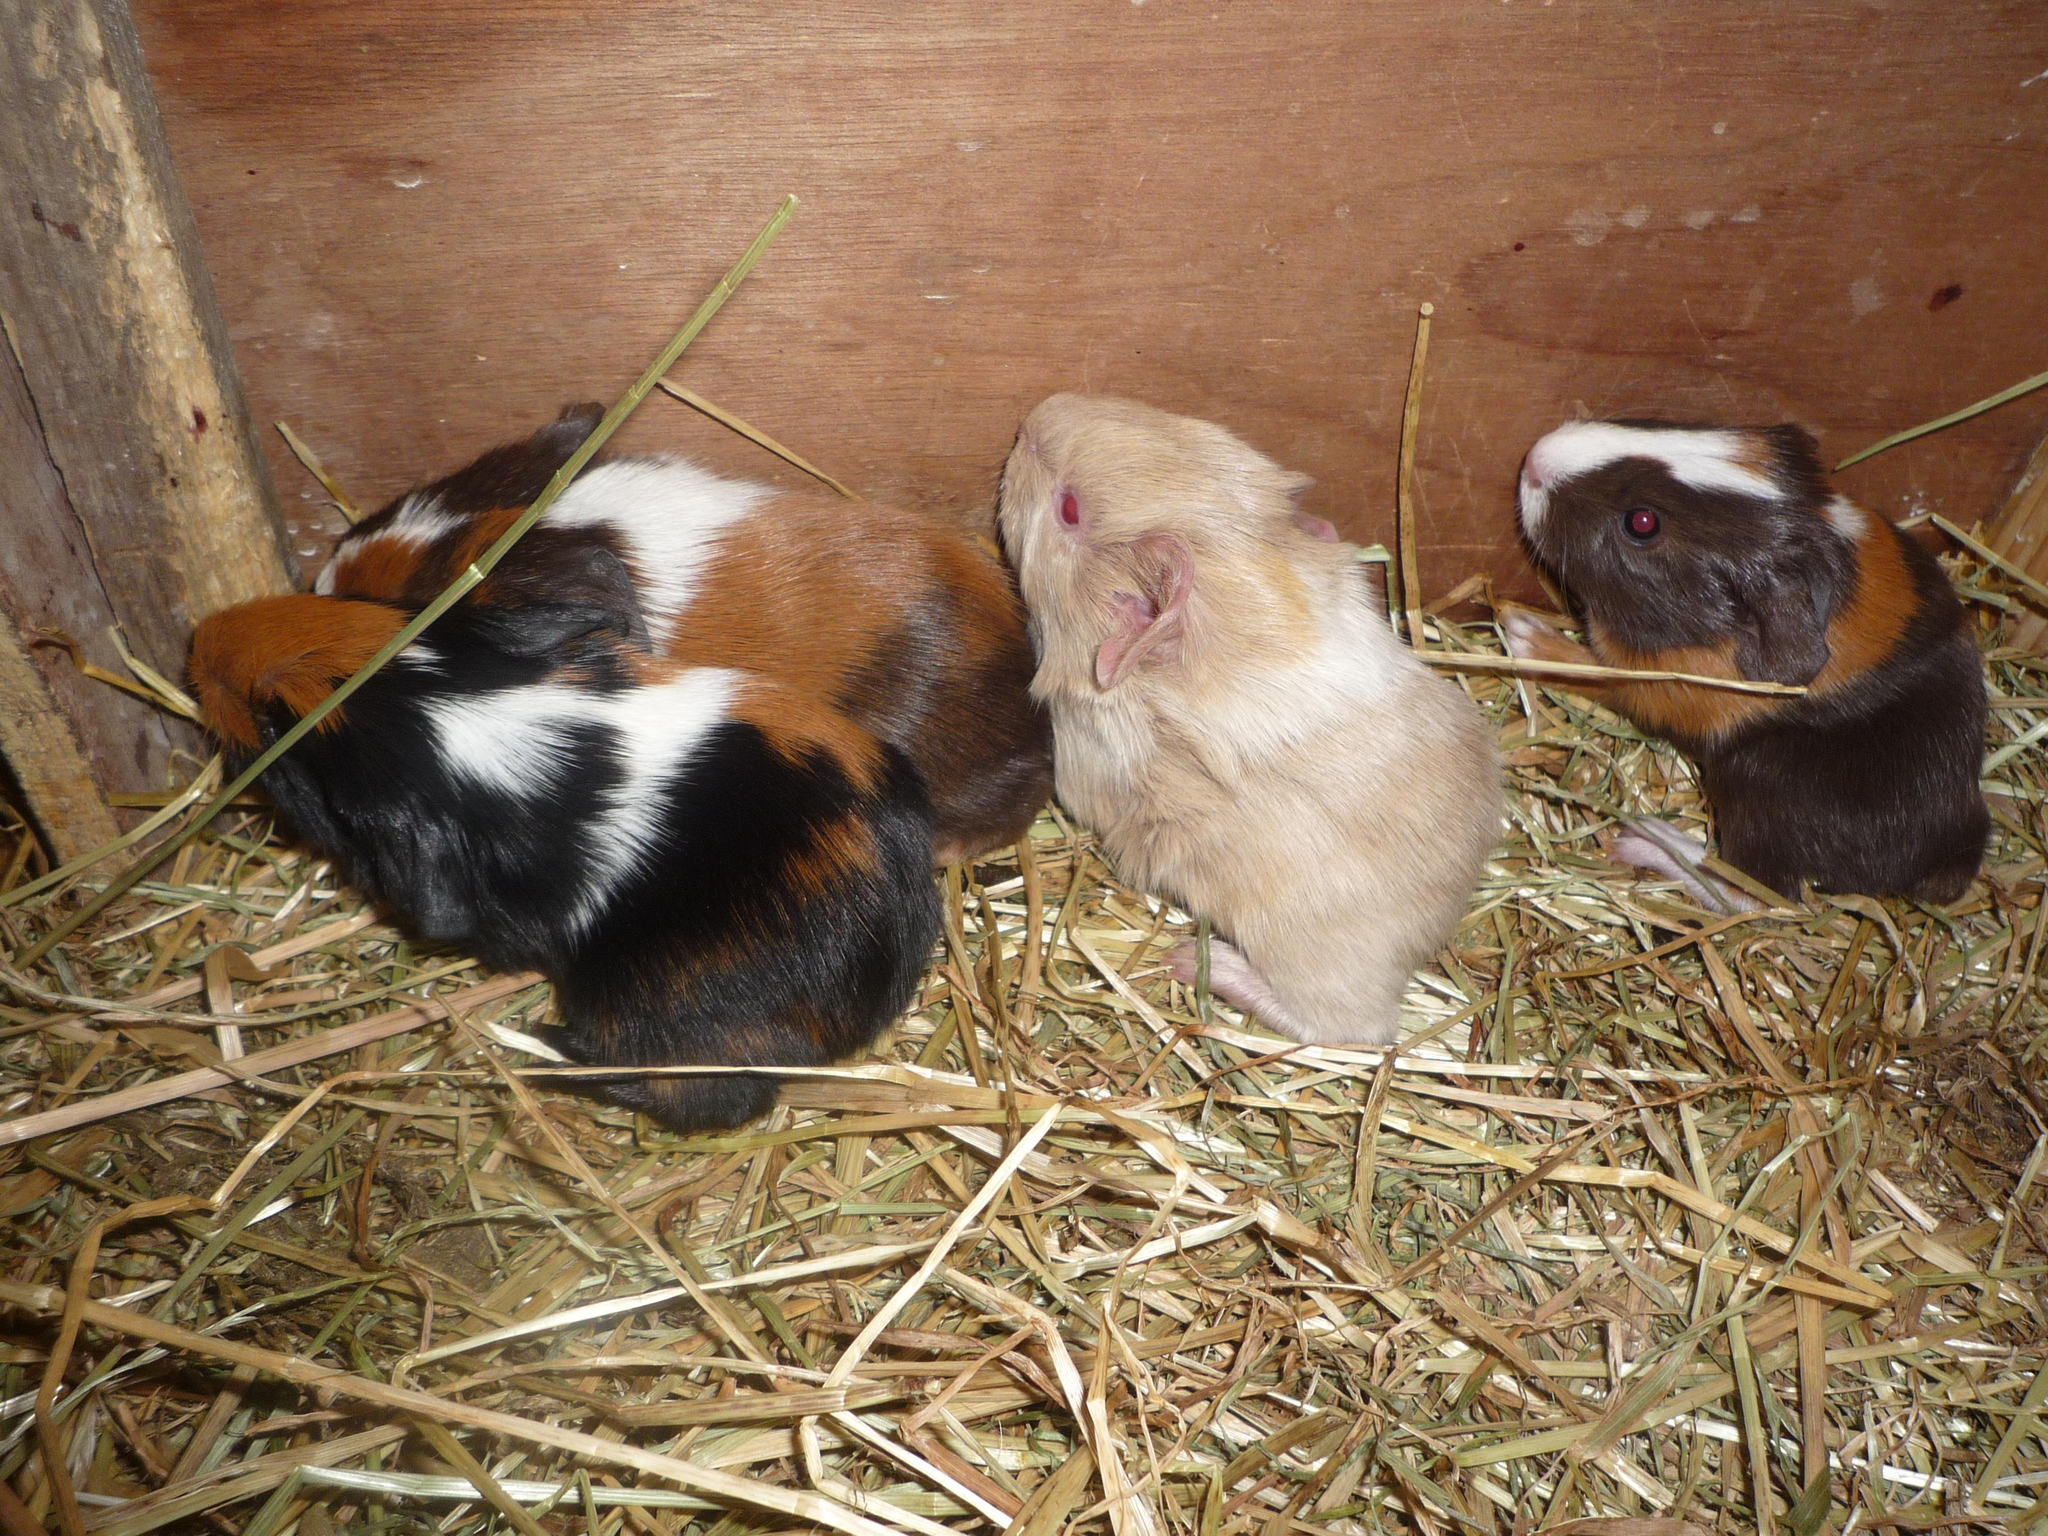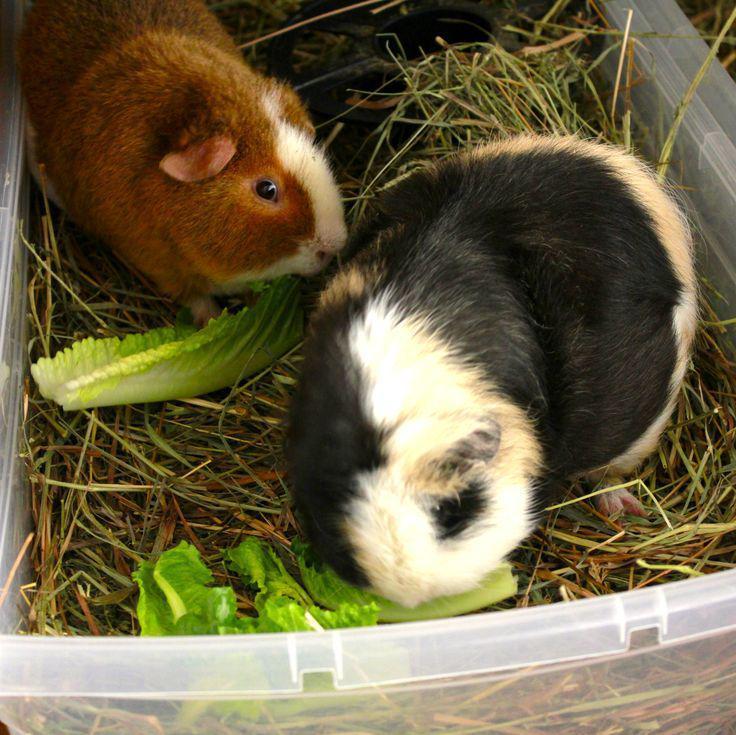The first image is the image on the left, the second image is the image on the right. For the images shown, is this caption "There is a bowl in the image on the right." true? Answer yes or no. No. 